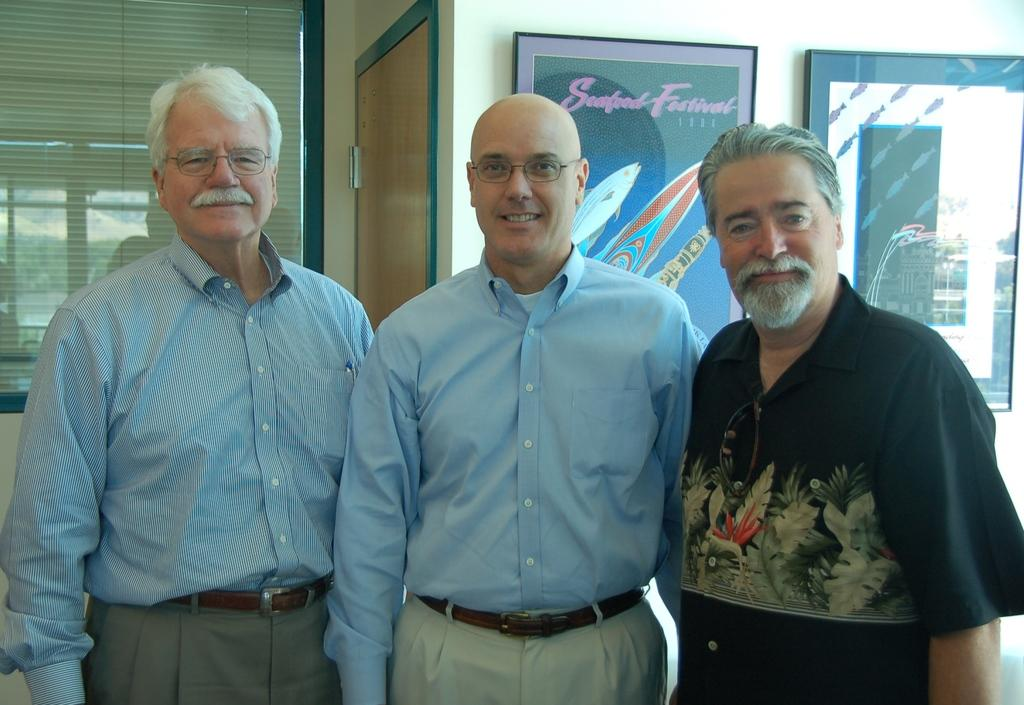How many people are in the image? There are three persons standing in the center of the image. What can be seen in the background of the image? There is a door in the background of the image. What is the window made of in the image? The window has glass in the image. What is on the wall in the image? There is a wall with photo frames on it. How many cats are sitting on the canvas in the image? There is no canvas or cats present in the image. 